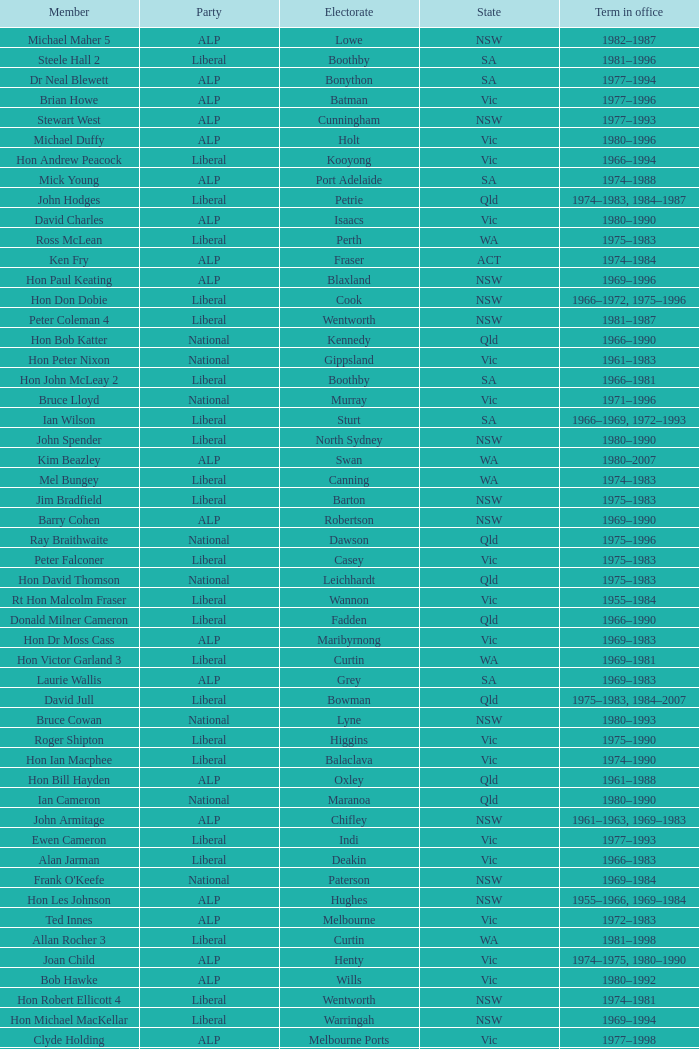Which party had a member from the state of Vic and an Electorate called Wannon? Liberal. 